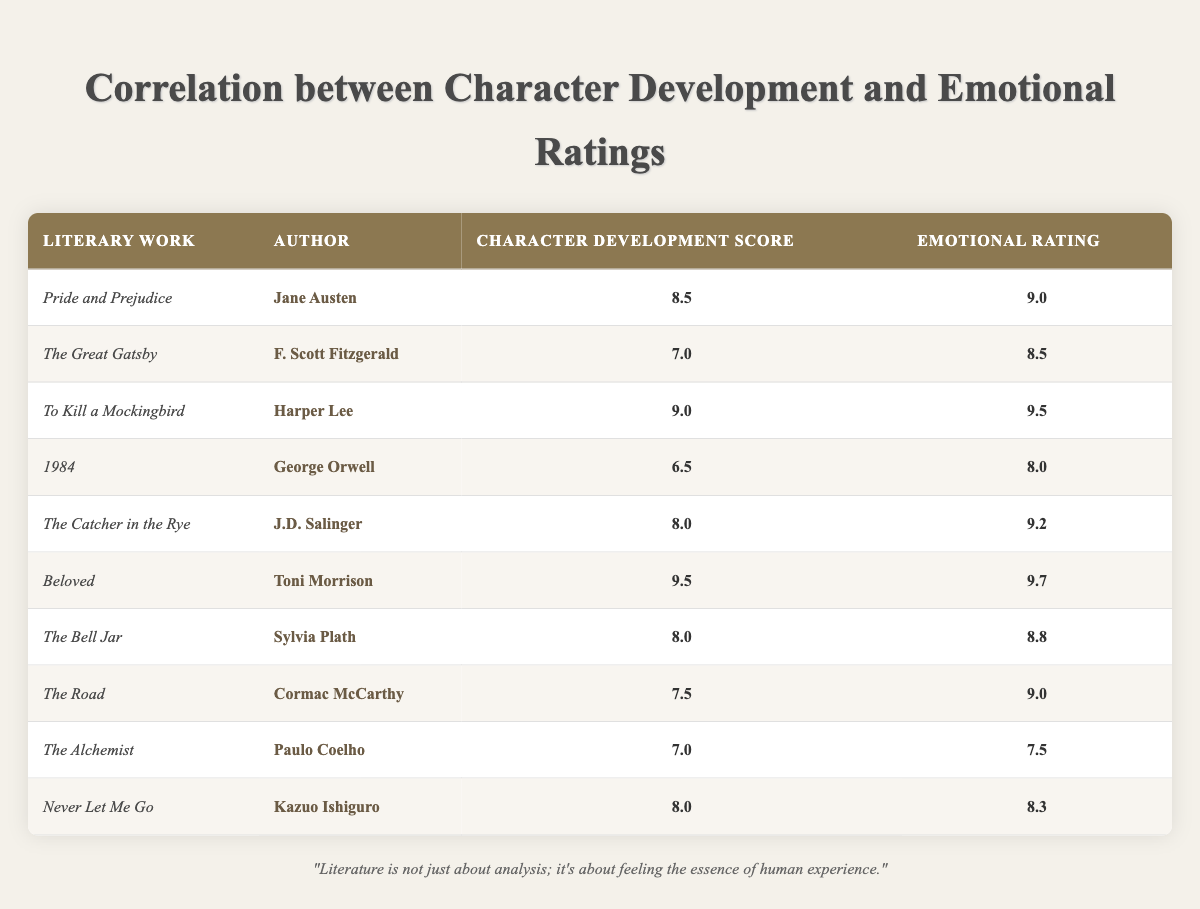What is the character development score for "Beloved"? In the table, I locate the row for "Beloved" by Toni Morrison, where the character development score is explicitly listed. The score is 9.5.
Answer: 9.5 Which literary work has the highest emotional rating? By scanning the emotional rating column, I identify that "Beloved" has an emotional rating of 9.7, which is the highest among all the works listed.
Answer: Beloved What is the average character development score of all the works listed? To calculate the average, I first sum the character development scores: (8.5 + 7.0 + 9.0 + 6.5 + 8.0 + 9.5 + 8.0 + 7.5 + 7.0 + 8.0) = 70.0. Then, I divide this by the total number of works, which is 10. Hence, the average is 70.0 / 10 = 7.0.
Answer: 7.0 Is the emotional rating for "1984" higher than its character development score? I check the emotional rating for "1984," which is 8.0, and the character development score, which is 6.5. Since 8.0 is greater than 6.5, I conclude that the statement is true.
Answer: Yes What is the difference between the emotional rating of "To Kill a Mockingbird" and "The Alchemist"? I find the emotional rating for "To Kill a Mockingbird" is 9.5 and for "The Alchemist" is 7.5. The difference equals 9.5 - 7.5 = 2.0.
Answer: 2.0 Which authors have scores above 8.0 in both character development and emotional ratings? I analyze the table for authors with scores greater than 8.0. The authors with both metrics meeting this criterion are Toni Morrison ("Beloved") and Harper Lee ("To Kill a Mockingbird").
Answer: Toni Morrison, Harper Lee What is the median character development score? To find the median, I first list the character development scores in order: 6.5, 7.0, 7.0, 7.5, 8.0, 8.0, 8.5, 9.0, 9.5. The median is the middle value, which is 8.0 (the average of the two middle values: 8.0 and 8.5, is not needed since it's an odd count).
Answer: 8.0 Which literary work has a character development score lower than 8.0 but an emotional rating higher than 8.5? Looking at the character development score lower than 8.0, I find "The Great Gatsby" with 7.0 and "The Alchemist" with 7.0. Among them, only "The Great Gatsby" has an emotional rating higher than 8.5 (8.5).
Answer: The Great Gatsby How many works have an emotional rating above 9.0? I check the emotional ratings in the table and count those above 9.0: "Pride and Prejudice" (9.0), "To Kill a Mockingbird" (9.5), "The Catcher in the Rye" (9.2), "Beloved" (9.7), and "The Road" (9.0). Thus, a total of 4 works exceed 9.0.
Answer: 4 